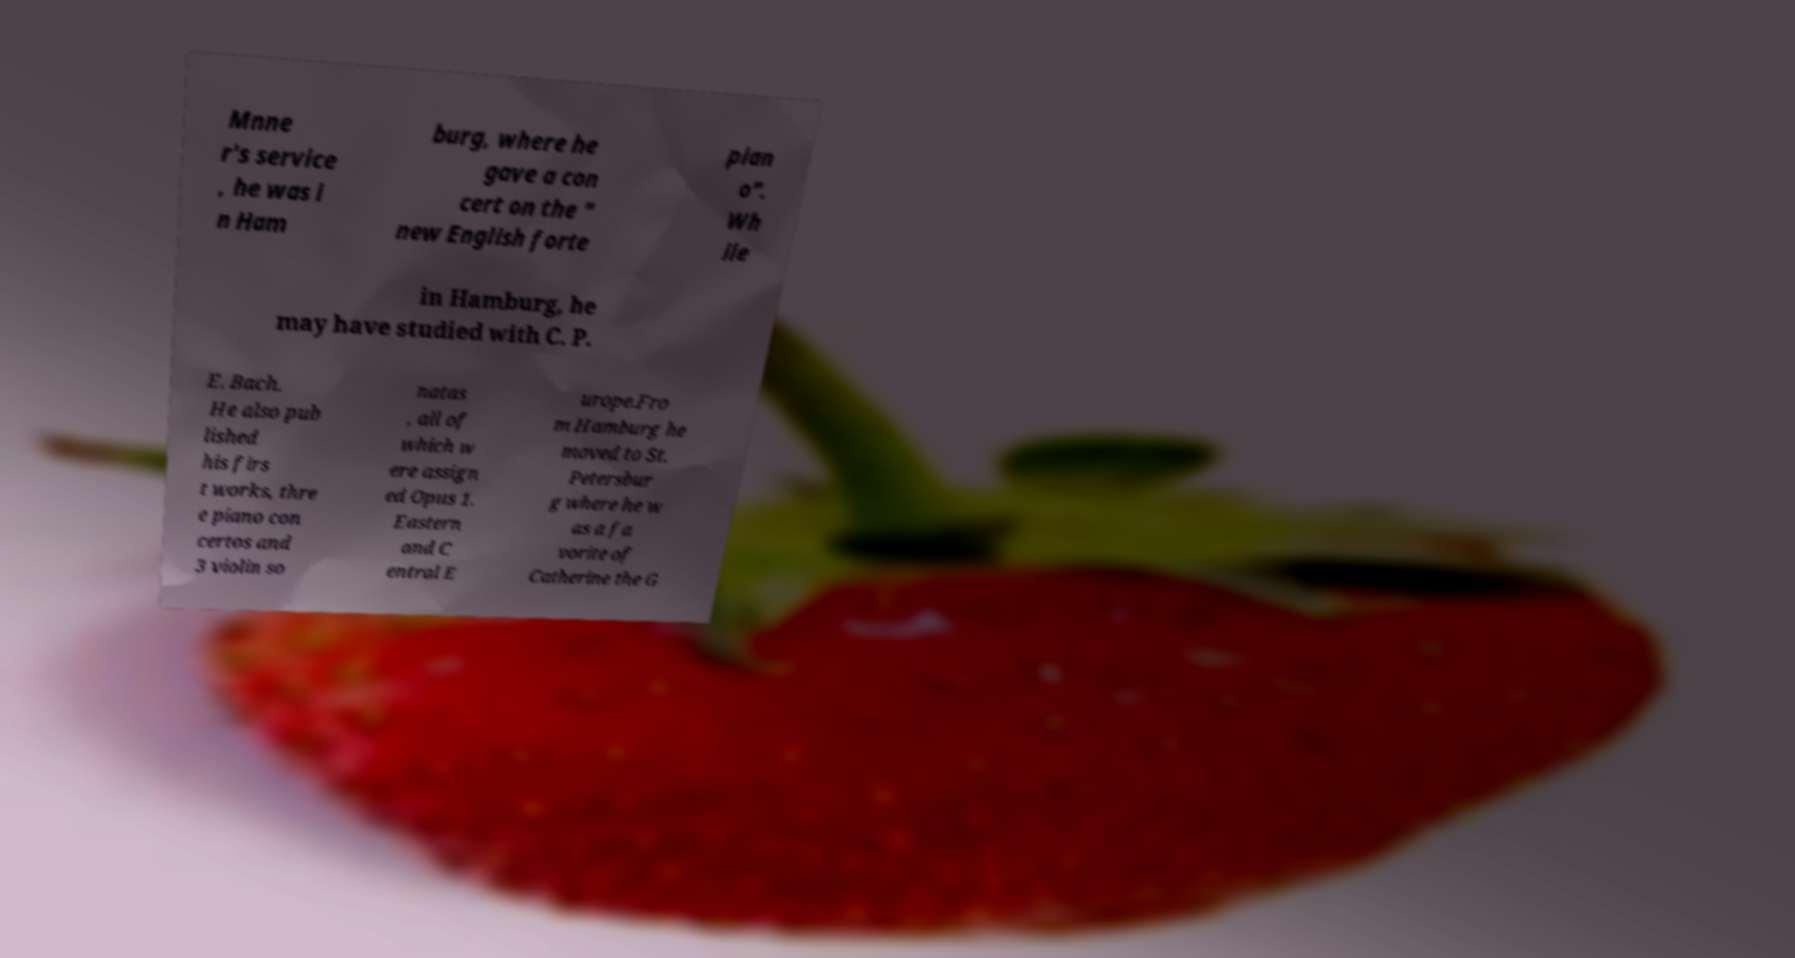There's text embedded in this image that I need extracted. Can you transcribe it verbatim? Mnne r's service , he was i n Ham burg, where he gave a con cert on the " new English forte pian o". Wh ile in Hamburg, he may have studied with C. P. E. Bach. He also pub lished his firs t works, thre e piano con certos and 3 violin so natas , all of which w ere assign ed Opus 1. Eastern and C entral E urope.Fro m Hamburg he moved to St. Petersbur g where he w as a fa vorite of Catherine the G 